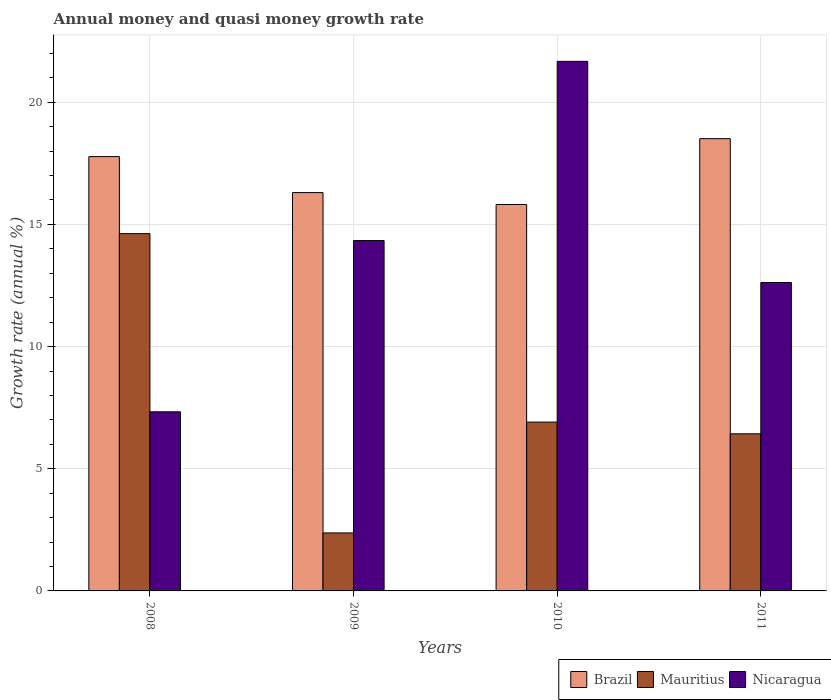How many different coloured bars are there?
Offer a terse response. 3. How many groups of bars are there?
Provide a short and direct response. 4. Are the number of bars per tick equal to the number of legend labels?
Ensure brevity in your answer.  Yes. Are the number of bars on each tick of the X-axis equal?
Your answer should be compact. Yes. How many bars are there on the 2nd tick from the left?
Offer a terse response. 3. What is the growth rate in Mauritius in 2009?
Keep it short and to the point. 2.37. Across all years, what is the maximum growth rate in Brazil?
Your response must be concise. 18.51. Across all years, what is the minimum growth rate in Mauritius?
Offer a terse response. 2.37. What is the total growth rate in Brazil in the graph?
Offer a very short reply. 68.4. What is the difference between the growth rate in Brazil in 2008 and that in 2010?
Your answer should be very brief. 1.96. What is the difference between the growth rate in Mauritius in 2011 and the growth rate in Brazil in 2008?
Provide a succinct answer. -11.35. What is the average growth rate in Brazil per year?
Your answer should be compact. 17.1. In the year 2008, what is the difference between the growth rate in Nicaragua and growth rate in Mauritius?
Your answer should be compact. -7.29. What is the ratio of the growth rate in Mauritius in 2008 to that in 2009?
Your answer should be very brief. 6.16. What is the difference between the highest and the second highest growth rate in Mauritius?
Offer a terse response. 7.71. What is the difference between the highest and the lowest growth rate in Brazil?
Offer a terse response. 2.69. In how many years, is the growth rate in Nicaragua greater than the average growth rate in Nicaragua taken over all years?
Make the answer very short. 2. Is the sum of the growth rate in Brazil in 2008 and 2011 greater than the maximum growth rate in Mauritius across all years?
Give a very brief answer. Yes. What does the 2nd bar from the left in 2010 represents?
Offer a very short reply. Mauritius. What does the 1st bar from the right in 2008 represents?
Ensure brevity in your answer.  Nicaragua. Is it the case that in every year, the sum of the growth rate in Mauritius and growth rate in Nicaragua is greater than the growth rate in Brazil?
Offer a very short reply. Yes. How many years are there in the graph?
Offer a very short reply. 4. Are the values on the major ticks of Y-axis written in scientific E-notation?
Ensure brevity in your answer.  No. Does the graph contain any zero values?
Offer a terse response. No. Does the graph contain grids?
Provide a short and direct response. Yes. Where does the legend appear in the graph?
Your answer should be compact. Bottom right. How many legend labels are there?
Offer a terse response. 3. How are the legend labels stacked?
Offer a terse response. Horizontal. What is the title of the graph?
Make the answer very short. Annual money and quasi money growth rate. Does "Sao Tome and Principe" appear as one of the legend labels in the graph?
Provide a short and direct response. No. What is the label or title of the Y-axis?
Your response must be concise. Growth rate (annual %). What is the Growth rate (annual %) in Brazil in 2008?
Ensure brevity in your answer.  17.78. What is the Growth rate (annual %) of Mauritius in 2008?
Offer a terse response. 14.62. What is the Growth rate (annual %) in Nicaragua in 2008?
Make the answer very short. 7.33. What is the Growth rate (annual %) of Brazil in 2009?
Your response must be concise. 16.3. What is the Growth rate (annual %) in Mauritius in 2009?
Ensure brevity in your answer.  2.37. What is the Growth rate (annual %) in Nicaragua in 2009?
Make the answer very short. 14.34. What is the Growth rate (annual %) in Brazil in 2010?
Your answer should be compact. 15.82. What is the Growth rate (annual %) of Mauritius in 2010?
Make the answer very short. 6.91. What is the Growth rate (annual %) of Nicaragua in 2010?
Keep it short and to the point. 21.67. What is the Growth rate (annual %) of Brazil in 2011?
Provide a succinct answer. 18.51. What is the Growth rate (annual %) of Mauritius in 2011?
Keep it short and to the point. 6.43. What is the Growth rate (annual %) of Nicaragua in 2011?
Your answer should be compact. 12.62. Across all years, what is the maximum Growth rate (annual %) in Brazil?
Make the answer very short. 18.51. Across all years, what is the maximum Growth rate (annual %) of Mauritius?
Keep it short and to the point. 14.62. Across all years, what is the maximum Growth rate (annual %) of Nicaragua?
Offer a terse response. 21.67. Across all years, what is the minimum Growth rate (annual %) in Brazil?
Your answer should be very brief. 15.82. Across all years, what is the minimum Growth rate (annual %) in Mauritius?
Offer a terse response. 2.37. Across all years, what is the minimum Growth rate (annual %) of Nicaragua?
Give a very brief answer. 7.33. What is the total Growth rate (annual %) of Brazil in the graph?
Offer a very short reply. 68.4. What is the total Growth rate (annual %) in Mauritius in the graph?
Provide a short and direct response. 30.34. What is the total Growth rate (annual %) in Nicaragua in the graph?
Give a very brief answer. 55.96. What is the difference between the Growth rate (annual %) of Brazil in 2008 and that in 2009?
Offer a very short reply. 1.47. What is the difference between the Growth rate (annual %) of Mauritius in 2008 and that in 2009?
Your answer should be very brief. 12.25. What is the difference between the Growth rate (annual %) of Nicaragua in 2008 and that in 2009?
Keep it short and to the point. -7.01. What is the difference between the Growth rate (annual %) in Brazil in 2008 and that in 2010?
Make the answer very short. 1.96. What is the difference between the Growth rate (annual %) of Mauritius in 2008 and that in 2010?
Your answer should be compact. 7.71. What is the difference between the Growth rate (annual %) of Nicaragua in 2008 and that in 2010?
Offer a terse response. -14.34. What is the difference between the Growth rate (annual %) of Brazil in 2008 and that in 2011?
Ensure brevity in your answer.  -0.73. What is the difference between the Growth rate (annual %) in Mauritius in 2008 and that in 2011?
Ensure brevity in your answer.  8.19. What is the difference between the Growth rate (annual %) in Nicaragua in 2008 and that in 2011?
Your answer should be very brief. -5.29. What is the difference between the Growth rate (annual %) in Brazil in 2009 and that in 2010?
Provide a succinct answer. 0.49. What is the difference between the Growth rate (annual %) of Mauritius in 2009 and that in 2010?
Your answer should be very brief. -4.54. What is the difference between the Growth rate (annual %) of Nicaragua in 2009 and that in 2010?
Your answer should be compact. -7.33. What is the difference between the Growth rate (annual %) of Brazil in 2009 and that in 2011?
Give a very brief answer. -2.21. What is the difference between the Growth rate (annual %) in Mauritius in 2009 and that in 2011?
Provide a succinct answer. -4.06. What is the difference between the Growth rate (annual %) in Nicaragua in 2009 and that in 2011?
Your answer should be very brief. 1.72. What is the difference between the Growth rate (annual %) in Brazil in 2010 and that in 2011?
Your answer should be compact. -2.69. What is the difference between the Growth rate (annual %) of Mauritius in 2010 and that in 2011?
Keep it short and to the point. 0.48. What is the difference between the Growth rate (annual %) of Nicaragua in 2010 and that in 2011?
Keep it short and to the point. 9.05. What is the difference between the Growth rate (annual %) in Brazil in 2008 and the Growth rate (annual %) in Mauritius in 2009?
Provide a succinct answer. 15.4. What is the difference between the Growth rate (annual %) of Brazil in 2008 and the Growth rate (annual %) of Nicaragua in 2009?
Ensure brevity in your answer.  3.44. What is the difference between the Growth rate (annual %) in Mauritius in 2008 and the Growth rate (annual %) in Nicaragua in 2009?
Ensure brevity in your answer.  0.28. What is the difference between the Growth rate (annual %) of Brazil in 2008 and the Growth rate (annual %) of Mauritius in 2010?
Provide a succinct answer. 10.87. What is the difference between the Growth rate (annual %) in Brazil in 2008 and the Growth rate (annual %) in Nicaragua in 2010?
Make the answer very short. -3.9. What is the difference between the Growth rate (annual %) of Mauritius in 2008 and the Growth rate (annual %) of Nicaragua in 2010?
Give a very brief answer. -7.05. What is the difference between the Growth rate (annual %) of Brazil in 2008 and the Growth rate (annual %) of Mauritius in 2011?
Give a very brief answer. 11.35. What is the difference between the Growth rate (annual %) of Brazil in 2008 and the Growth rate (annual %) of Nicaragua in 2011?
Ensure brevity in your answer.  5.15. What is the difference between the Growth rate (annual %) of Mauritius in 2008 and the Growth rate (annual %) of Nicaragua in 2011?
Your answer should be very brief. 2. What is the difference between the Growth rate (annual %) in Brazil in 2009 and the Growth rate (annual %) in Mauritius in 2010?
Keep it short and to the point. 9.39. What is the difference between the Growth rate (annual %) in Brazil in 2009 and the Growth rate (annual %) in Nicaragua in 2010?
Provide a short and direct response. -5.37. What is the difference between the Growth rate (annual %) of Mauritius in 2009 and the Growth rate (annual %) of Nicaragua in 2010?
Your response must be concise. -19.3. What is the difference between the Growth rate (annual %) of Brazil in 2009 and the Growth rate (annual %) of Mauritius in 2011?
Your answer should be very brief. 9.87. What is the difference between the Growth rate (annual %) in Brazil in 2009 and the Growth rate (annual %) in Nicaragua in 2011?
Offer a very short reply. 3.68. What is the difference between the Growth rate (annual %) in Mauritius in 2009 and the Growth rate (annual %) in Nicaragua in 2011?
Your answer should be compact. -10.25. What is the difference between the Growth rate (annual %) of Brazil in 2010 and the Growth rate (annual %) of Mauritius in 2011?
Provide a succinct answer. 9.39. What is the difference between the Growth rate (annual %) of Brazil in 2010 and the Growth rate (annual %) of Nicaragua in 2011?
Your response must be concise. 3.19. What is the difference between the Growth rate (annual %) of Mauritius in 2010 and the Growth rate (annual %) of Nicaragua in 2011?
Give a very brief answer. -5.71. What is the average Growth rate (annual %) of Brazil per year?
Ensure brevity in your answer.  17.1. What is the average Growth rate (annual %) in Mauritius per year?
Make the answer very short. 7.58. What is the average Growth rate (annual %) in Nicaragua per year?
Offer a very short reply. 13.99. In the year 2008, what is the difference between the Growth rate (annual %) of Brazil and Growth rate (annual %) of Mauritius?
Your answer should be very brief. 3.15. In the year 2008, what is the difference between the Growth rate (annual %) of Brazil and Growth rate (annual %) of Nicaragua?
Provide a succinct answer. 10.45. In the year 2008, what is the difference between the Growth rate (annual %) in Mauritius and Growth rate (annual %) in Nicaragua?
Offer a terse response. 7.29. In the year 2009, what is the difference between the Growth rate (annual %) in Brazil and Growth rate (annual %) in Mauritius?
Offer a terse response. 13.93. In the year 2009, what is the difference between the Growth rate (annual %) in Brazil and Growth rate (annual %) in Nicaragua?
Your answer should be very brief. 1.96. In the year 2009, what is the difference between the Growth rate (annual %) in Mauritius and Growth rate (annual %) in Nicaragua?
Keep it short and to the point. -11.96. In the year 2010, what is the difference between the Growth rate (annual %) in Brazil and Growth rate (annual %) in Mauritius?
Give a very brief answer. 8.91. In the year 2010, what is the difference between the Growth rate (annual %) in Brazil and Growth rate (annual %) in Nicaragua?
Your response must be concise. -5.86. In the year 2010, what is the difference between the Growth rate (annual %) of Mauritius and Growth rate (annual %) of Nicaragua?
Give a very brief answer. -14.76. In the year 2011, what is the difference between the Growth rate (annual %) in Brazil and Growth rate (annual %) in Mauritius?
Ensure brevity in your answer.  12.08. In the year 2011, what is the difference between the Growth rate (annual %) in Brazil and Growth rate (annual %) in Nicaragua?
Make the answer very short. 5.89. In the year 2011, what is the difference between the Growth rate (annual %) in Mauritius and Growth rate (annual %) in Nicaragua?
Give a very brief answer. -6.19. What is the ratio of the Growth rate (annual %) of Brazil in 2008 to that in 2009?
Provide a succinct answer. 1.09. What is the ratio of the Growth rate (annual %) of Mauritius in 2008 to that in 2009?
Give a very brief answer. 6.16. What is the ratio of the Growth rate (annual %) in Nicaragua in 2008 to that in 2009?
Ensure brevity in your answer.  0.51. What is the ratio of the Growth rate (annual %) of Brazil in 2008 to that in 2010?
Offer a very short reply. 1.12. What is the ratio of the Growth rate (annual %) in Mauritius in 2008 to that in 2010?
Give a very brief answer. 2.12. What is the ratio of the Growth rate (annual %) of Nicaragua in 2008 to that in 2010?
Provide a short and direct response. 0.34. What is the ratio of the Growth rate (annual %) in Brazil in 2008 to that in 2011?
Your answer should be compact. 0.96. What is the ratio of the Growth rate (annual %) of Mauritius in 2008 to that in 2011?
Provide a short and direct response. 2.27. What is the ratio of the Growth rate (annual %) in Nicaragua in 2008 to that in 2011?
Your answer should be compact. 0.58. What is the ratio of the Growth rate (annual %) in Brazil in 2009 to that in 2010?
Your answer should be very brief. 1.03. What is the ratio of the Growth rate (annual %) in Mauritius in 2009 to that in 2010?
Keep it short and to the point. 0.34. What is the ratio of the Growth rate (annual %) of Nicaragua in 2009 to that in 2010?
Offer a very short reply. 0.66. What is the ratio of the Growth rate (annual %) of Brazil in 2009 to that in 2011?
Offer a terse response. 0.88. What is the ratio of the Growth rate (annual %) in Mauritius in 2009 to that in 2011?
Your answer should be very brief. 0.37. What is the ratio of the Growth rate (annual %) of Nicaragua in 2009 to that in 2011?
Offer a very short reply. 1.14. What is the ratio of the Growth rate (annual %) of Brazil in 2010 to that in 2011?
Offer a very short reply. 0.85. What is the ratio of the Growth rate (annual %) in Mauritius in 2010 to that in 2011?
Keep it short and to the point. 1.07. What is the ratio of the Growth rate (annual %) in Nicaragua in 2010 to that in 2011?
Ensure brevity in your answer.  1.72. What is the difference between the highest and the second highest Growth rate (annual %) of Brazil?
Your answer should be compact. 0.73. What is the difference between the highest and the second highest Growth rate (annual %) in Mauritius?
Your answer should be compact. 7.71. What is the difference between the highest and the second highest Growth rate (annual %) of Nicaragua?
Your response must be concise. 7.33. What is the difference between the highest and the lowest Growth rate (annual %) in Brazil?
Your response must be concise. 2.69. What is the difference between the highest and the lowest Growth rate (annual %) in Mauritius?
Your answer should be very brief. 12.25. What is the difference between the highest and the lowest Growth rate (annual %) of Nicaragua?
Make the answer very short. 14.34. 